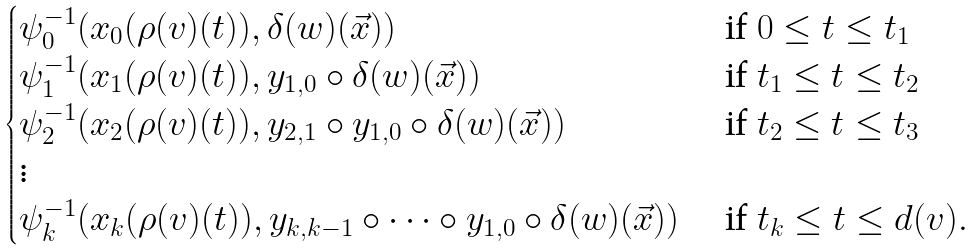<formula> <loc_0><loc_0><loc_500><loc_500>\begin{cases} \psi _ { 0 } ^ { - 1 } ( x _ { 0 } ( \rho ( v ) ( t ) ) , \delta ( w ) ( \vec { x } ) ) & \text { if $0\leq t\leq t_{1}$} \\ \psi _ { 1 } ^ { - 1 } ( x _ { 1 } ( \rho ( v ) ( t ) ) , y _ { 1 , 0 } \circ \delta ( w ) ( \vec { x } ) ) & \text { if $t_{1}\leq t\leq t_{2}$} \\ \psi _ { 2 } ^ { - 1 } ( x _ { 2 } ( \rho ( v ) ( t ) ) , y _ { 2 , 1 } \circ y _ { 1 , 0 } \circ \delta ( w ) ( \vec { x } ) ) & \text { if $t_{2}\leq t\leq t_{3}$} \\ \vdots \\ \psi _ { k } ^ { - 1 } ( x _ { k } ( \rho ( v ) ( t ) ) , y _ { k , k - 1 } \circ \cdots \circ y _ { 1 , 0 } \circ \delta ( w ) ( \vec { x } ) ) & \text { if $t_{k}\leq t\leq d(v)$} . \end{cases}</formula> 